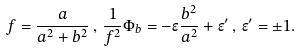<formula> <loc_0><loc_0><loc_500><loc_500>f = \frac { a } { a ^ { 2 } + b ^ { 2 } } \, , \, \frac { 1 } { f ^ { 2 } } { \Phi } _ { b } = - \epsilon \frac { b ^ { 2 } } { a ^ { 2 } } + { \epsilon } ^ { \prime } \, , \, { \epsilon } ^ { \prime } = \pm 1 .</formula> 